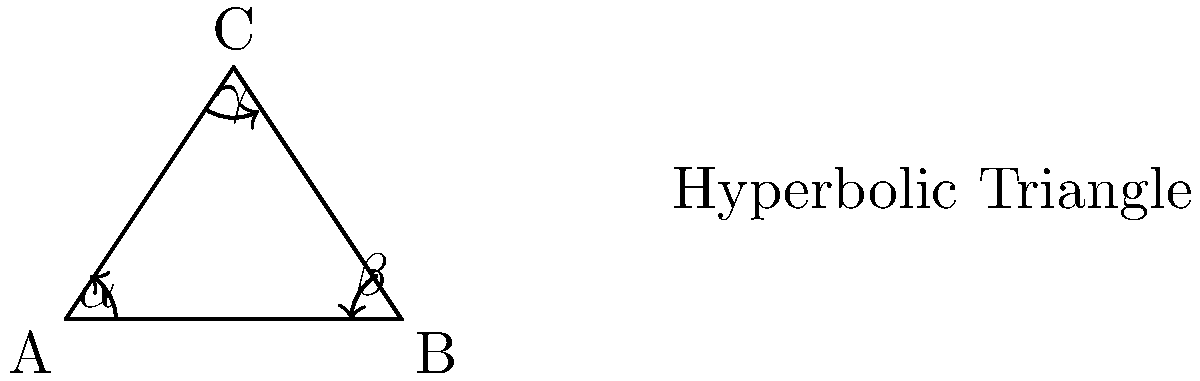Hey champ, remember when we used to practice our footwork in that old gym? Well, I've got a different kind of triangle for you today. In a hyperbolic triangle like the one shown, what can you tell me about the sum of its interior angles $(\alpha + \beta + \gamma)$ compared to a regular triangle on a flat surface? Alright, let's break this down step-by-step, just like we used to analyze our opponents:

1) In Euclidean geometry (flat surface), we know the sum of interior angles of a triangle is always 180°.

2) However, in hyperbolic geometry, things work differently:

   a) The surface is curved negatively, like the inside of a saddle.
   b) This curvature affects how lines and angles behave.

3) In hyperbolic geometry, the sum of the interior angles of a triangle is always less than 180°.

4) The formula for the sum of angles in a hyperbolic triangle is:

   $\alpha + \beta + \gamma = \pi - A$

   Where $\pi$ is 180° in radians, and $A$ is the area of the triangle in the hyperbolic plane.

5) The larger the hyperbolic triangle, the smaller the sum of its angles.

6) This is because as the triangle gets larger, it covers more of the curved surface, increasing its area $A$.

7) As $A$ increases, the term $(\pi - A)$ decreases, resulting in a smaller sum of angles.

So, just like how we always kept our guard up in the ring, remember: in hyperbolic geometry, the sum of angles in a triangle is always on the defensive - it's less than 180°.
Answer: Less than 180° 